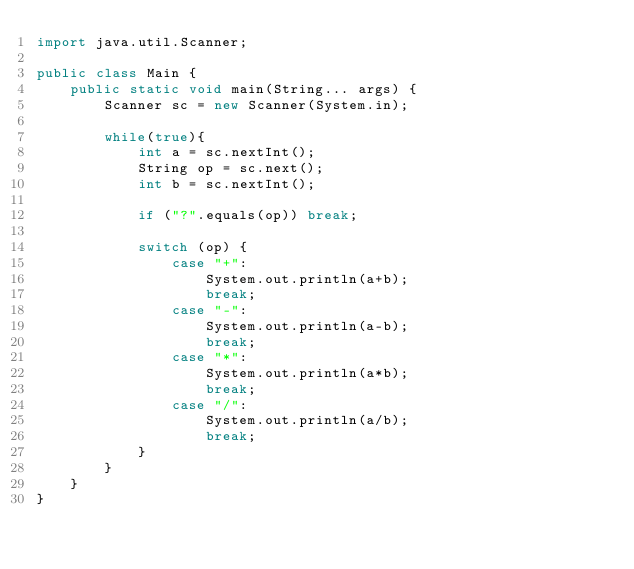Convert code to text. <code><loc_0><loc_0><loc_500><loc_500><_Java_>import java.util.Scanner;

public class Main {
    public static void main(String... args) {
        Scanner sc = new Scanner(System.in);

        while(true){
            int a = sc.nextInt();
            String op = sc.next();
            int b = sc.nextInt();

            if ("?".equals(op)) break;

            switch (op) {
                case "+":
                    System.out.println(a+b);
                    break;
                case "-":
                    System.out.println(a-b);
                    break;
                case "*":
                    System.out.println(a*b);
                    break;
                case "/":
                    System.out.println(a/b);
                    break;
            }
        }
    }
}
</code> 